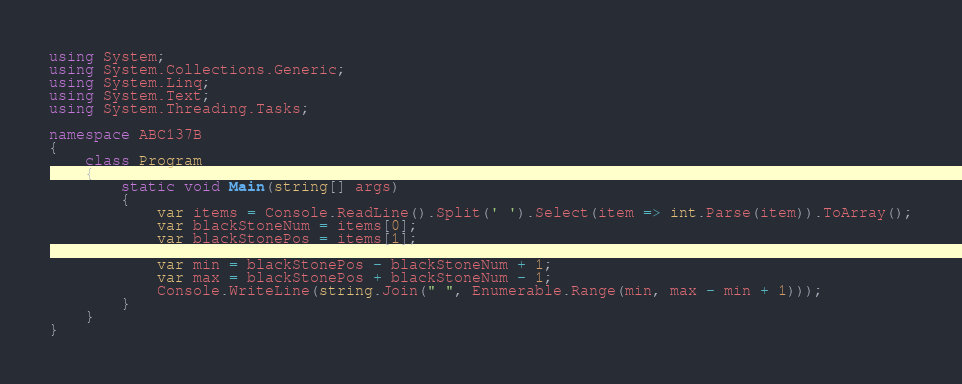<code> <loc_0><loc_0><loc_500><loc_500><_C#_>using System;
using System.Collections.Generic;
using System.Linq;
using System.Text;
using System.Threading.Tasks;

namespace ABC137B
{
    class Program
    {
        static void Main(string[] args)
        {
            var items = Console.ReadLine().Split(' ').Select(item => int.Parse(item)).ToArray();
            var blackStoneNum = items[0];
            var blackStonePos = items[1];

            var min = blackStonePos - blackStoneNum + 1;
            var max = blackStonePos + blackStoneNum - 1;
            Console.WriteLine(string.Join(" ", Enumerable.Range(min, max - min + 1)));
        }
    }
}
</code> 